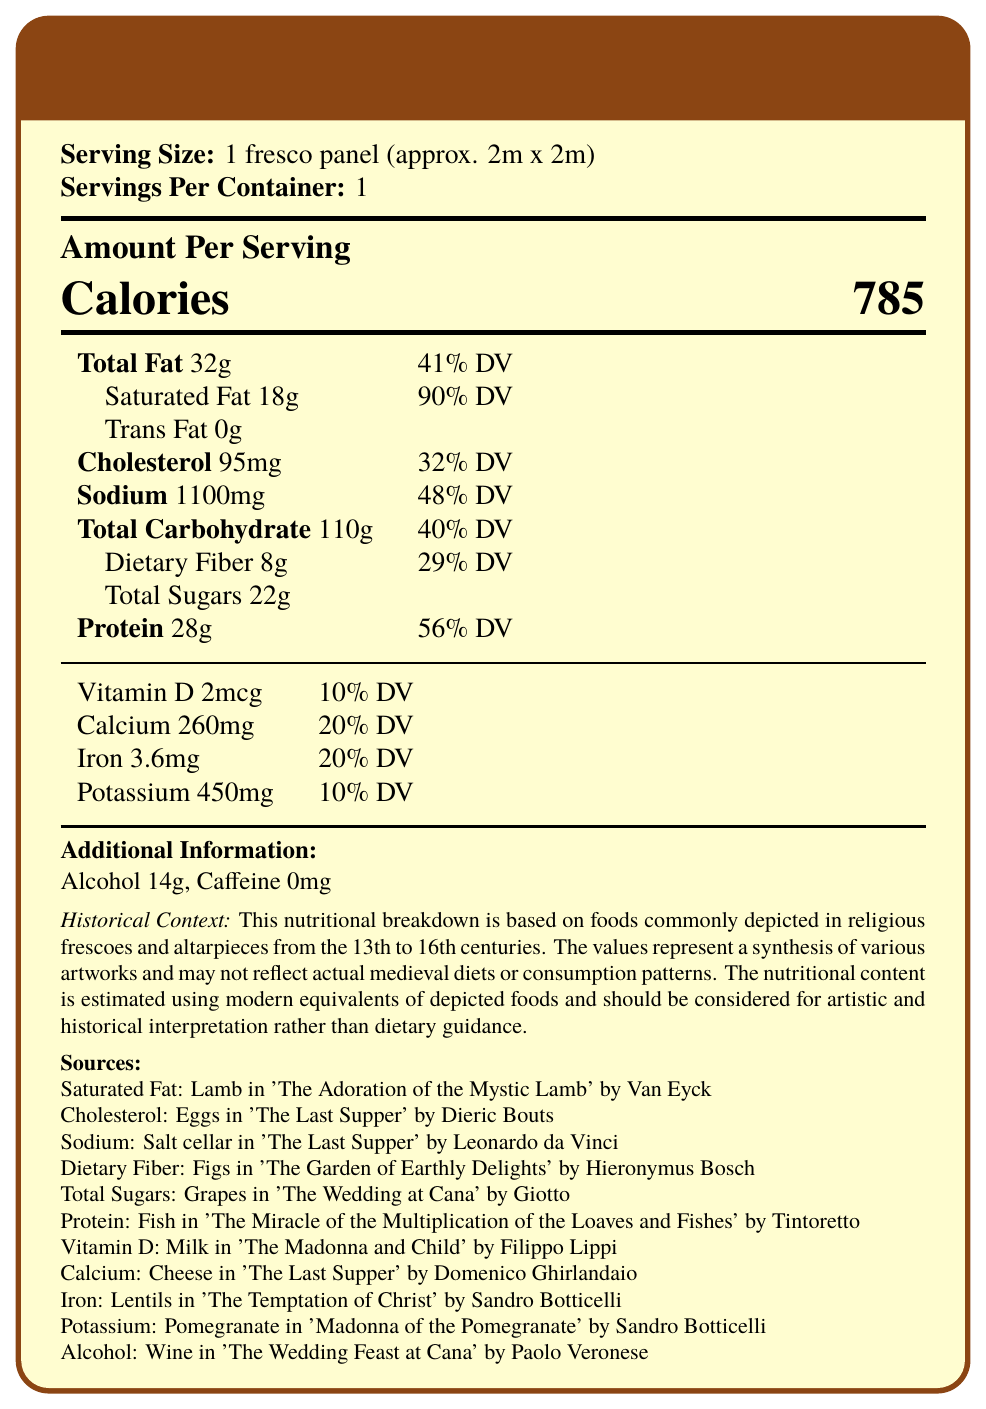what is the serving size? The document specifies the serving size as 1 fresco panel (approx. 2m x 2m).
Answer: 1 fresco panel (approx. 2m x 2m) how many calories are in one serving? The document states that there are 785 calories in one serving.
Answer: 785 calories what is the main source of saturated fat? The document lists Lamb in 'The Adoration of the Mystic Lamb' by Van Eyck as the source of saturated fat.
Answer: Lamb in 'The Adoration of the Mystic Lamb' by Van Eyck which artwork is cited for the cholesterol source? The document cites 'The Last Supper' by Dieric Bouts as the source of cholesterol.
Answer: 'The Last Supper' by Dieric Bouts how much sodium does one serving contain? The document states that one serving contains 1100 mg of sodium.
Answer: 1100 mg what is the source of dietary fiber? The document specifies that the source of dietary fiber is figs in 'The Garden of Earthly Delights' by Hieronymus Bosch.
Answer: Figs in 'The Garden of Earthly Delights' by Hieronymus Bosch how much protein is in one serving? The document indicates that there are 28g of protein in one serving.
Answer: 28g what is the daily value percentage of calcium? The document states that the daily value percentage of calcium is 20%.
Answer: 20% where does the alcohol content come from? A. Lamb B. Figs C. Wine D. Grapes The document lists Wine in 'The Wedding Feast at Cana' by Paolo Veronese as the source of alcohol.
Answer: C. Wine which of the following foods is not a source of potassium? A. Pomegranate B. Lentils C. Cheese D. Grapes The document specifies that pomegranate is the source of potassium, and cheese is cited as a source of calcium, not potassium.
Answer: C. Cheese is there any caffeine depicted in medieval religious art? The document states that caffeine is not commonly depicted in medieval religious art.
Answer: No summarize the main purpose of this document. The primary aim of the document is to illustrate the nutritional content of foods depicted in medieval religious artwork by using modern equivalents to estimate their values. It offers an artistic and historical perspective rather than dietary advice.
Answer: The document provides a nutritional breakdown of foods commonly depicted in religious frescoes and altarpieces from the 13th to 16th centuries, using modern equivalents to estimate the nutritional content. The information helps in the artistic and historical interpretation of medieval religious artworks rather than offering dietary guidance. what is the daily value percentage for total fat? The document states that the daily value percentage for total fat is 41%.
Answer: 41% which vitamin is supplied by 'The Madonna and Child' by Filippo Lippi? The document indicates that milk depicted in 'The Madonna and Child' by Filippo Lippi is the source of vitamin D.
Answer: Vitamin D from which artwork is the source of protein derived? The document lists fish in 'The Miracle of the Multiplication of the Loaves and Fishes' by Tintoretto as the source of protein.
Answer: 'The Miracle of the Multiplication of the Loaves and Fishes' by Tintoretto can the exact medieval diet be determined from this document? The document clearly states that the nutritional breakdown is a synthesis based on artworks and not reflective of actual medieval diets or consumption patterns.
Answer: Cannot be determined 